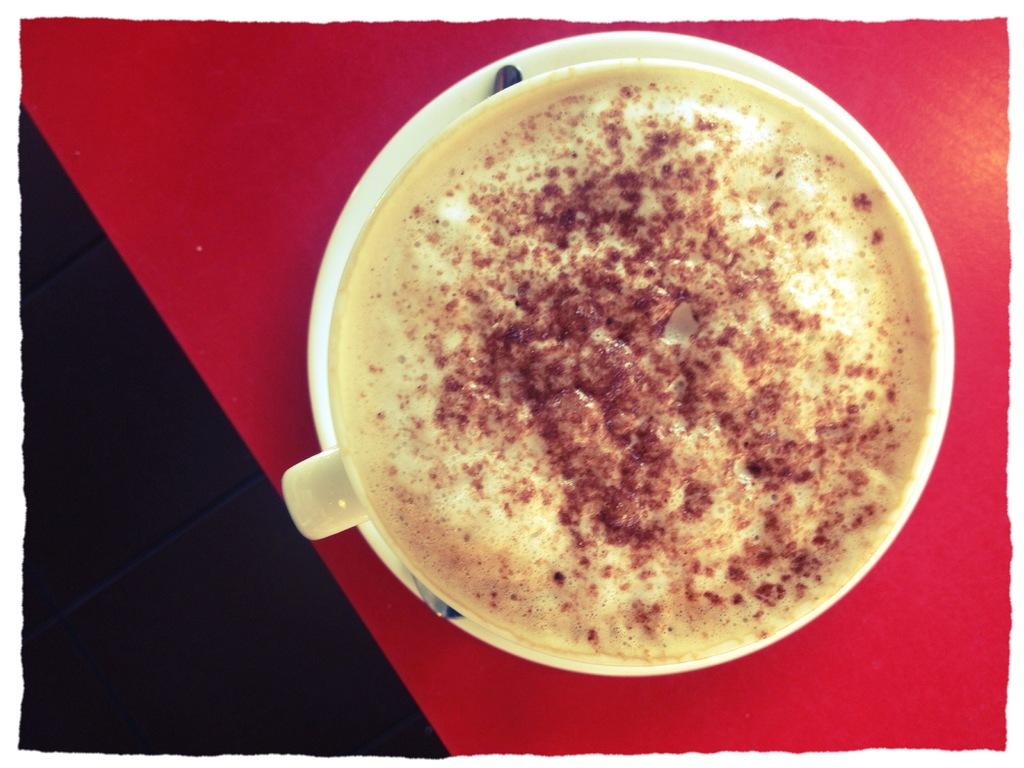What is in the cup that is visible in the image? There is a cup of coffee in the image. How is the cup of coffee supported in the image? The cup of coffee is placed on a saucer. What utensil is present in the image? There is a spoon in the image. On what surface is the spoon placed? The spoon is placed on a red color surface. How many muscles are flexed by the cup of coffee in the image? The cup of coffee is an inanimate object and does not have muscles, so this question cannot be answered. 